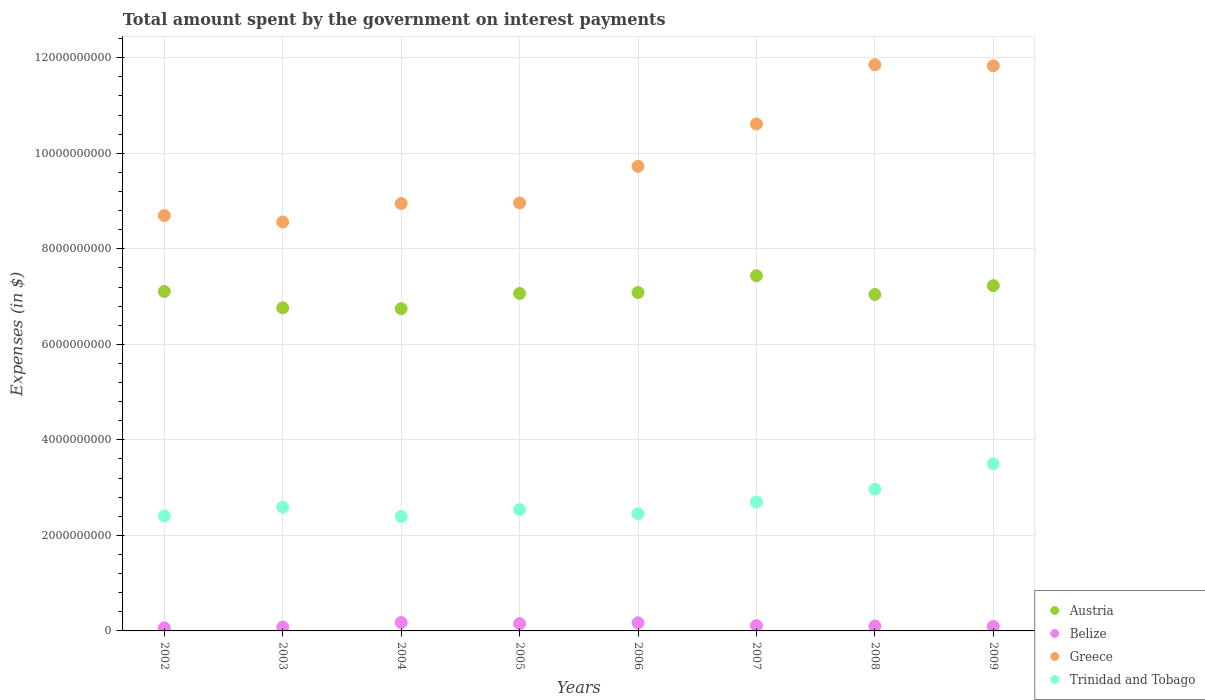What is the amount spent on interest payments by the government in Belize in 2004?
Give a very brief answer. 1.76e+08. Across all years, what is the maximum amount spent on interest payments by the government in Belize?
Your answer should be compact. 1.76e+08. Across all years, what is the minimum amount spent on interest payments by the government in Greece?
Provide a short and direct response. 8.56e+09. In which year was the amount spent on interest payments by the government in Belize maximum?
Your answer should be compact. 2004. What is the total amount spent on interest payments by the government in Austria in the graph?
Ensure brevity in your answer.  5.65e+1. What is the difference between the amount spent on interest payments by the government in Austria in 2002 and that in 2007?
Keep it short and to the point. -3.29e+08. What is the difference between the amount spent on interest payments by the government in Austria in 2003 and the amount spent on interest payments by the government in Trinidad and Tobago in 2005?
Make the answer very short. 4.22e+09. What is the average amount spent on interest payments by the government in Greece per year?
Keep it short and to the point. 9.90e+09. In the year 2005, what is the difference between the amount spent on interest payments by the government in Austria and amount spent on interest payments by the government in Greece?
Your response must be concise. -1.90e+09. In how many years, is the amount spent on interest payments by the government in Trinidad and Tobago greater than 3600000000 $?
Provide a succinct answer. 0. What is the ratio of the amount spent on interest payments by the government in Greece in 2008 to that in 2009?
Provide a succinct answer. 1. Is the amount spent on interest payments by the government in Greece in 2003 less than that in 2009?
Your answer should be very brief. Yes. Is the difference between the amount spent on interest payments by the government in Austria in 2002 and 2003 greater than the difference between the amount spent on interest payments by the government in Greece in 2002 and 2003?
Provide a short and direct response. Yes. What is the difference between the highest and the second highest amount spent on interest payments by the government in Greece?
Your answer should be very brief. 2.30e+07. What is the difference between the highest and the lowest amount spent on interest payments by the government in Trinidad and Tobago?
Provide a short and direct response. 1.10e+09. Is the sum of the amount spent on interest payments by the government in Austria in 2003 and 2005 greater than the maximum amount spent on interest payments by the government in Trinidad and Tobago across all years?
Your answer should be very brief. Yes. Is it the case that in every year, the sum of the amount spent on interest payments by the government in Trinidad and Tobago and amount spent on interest payments by the government in Belize  is greater than the sum of amount spent on interest payments by the government in Austria and amount spent on interest payments by the government in Greece?
Give a very brief answer. No. Is it the case that in every year, the sum of the amount spent on interest payments by the government in Austria and amount spent on interest payments by the government in Greece  is greater than the amount spent on interest payments by the government in Belize?
Make the answer very short. Yes. Is the amount spent on interest payments by the government in Belize strictly less than the amount spent on interest payments by the government in Trinidad and Tobago over the years?
Offer a very short reply. Yes. How many years are there in the graph?
Your answer should be very brief. 8. Where does the legend appear in the graph?
Give a very brief answer. Bottom right. How many legend labels are there?
Offer a terse response. 4. What is the title of the graph?
Offer a terse response. Total amount spent by the government on interest payments. Does "Canada" appear as one of the legend labels in the graph?
Your answer should be very brief. No. What is the label or title of the Y-axis?
Offer a terse response. Expenses (in $). What is the Expenses (in $) in Austria in 2002?
Offer a terse response. 7.11e+09. What is the Expenses (in $) of Belize in 2002?
Your answer should be very brief. 6.39e+07. What is the Expenses (in $) of Greece in 2002?
Keep it short and to the point. 8.70e+09. What is the Expenses (in $) in Trinidad and Tobago in 2002?
Provide a short and direct response. 2.41e+09. What is the Expenses (in $) of Austria in 2003?
Provide a succinct answer. 6.76e+09. What is the Expenses (in $) in Belize in 2003?
Give a very brief answer. 8.13e+07. What is the Expenses (in $) in Greece in 2003?
Offer a terse response. 8.56e+09. What is the Expenses (in $) in Trinidad and Tobago in 2003?
Provide a short and direct response. 2.59e+09. What is the Expenses (in $) in Austria in 2004?
Your answer should be very brief. 6.75e+09. What is the Expenses (in $) of Belize in 2004?
Your answer should be compact. 1.76e+08. What is the Expenses (in $) in Greece in 2004?
Provide a short and direct response. 8.95e+09. What is the Expenses (in $) of Trinidad and Tobago in 2004?
Provide a succinct answer. 2.40e+09. What is the Expenses (in $) in Austria in 2005?
Your answer should be very brief. 7.06e+09. What is the Expenses (in $) of Belize in 2005?
Ensure brevity in your answer.  1.54e+08. What is the Expenses (in $) in Greece in 2005?
Offer a very short reply. 8.96e+09. What is the Expenses (in $) in Trinidad and Tobago in 2005?
Offer a very short reply. 2.54e+09. What is the Expenses (in $) of Austria in 2006?
Give a very brief answer. 7.09e+09. What is the Expenses (in $) of Belize in 2006?
Your response must be concise. 1.70e+08. What is the Expenses (in $) in Greece in 2006?
Keep it short and to the point. 9.73e+09. What is the Expenses (in $) of Trinidad and Tobago in 2006?
Offer a terse response. 2.45e+09. What is the Expenses (in $) of Austria in 2007?
Give a very brief answer. 7.44e+09. What is the Expenses (in $) in Belize in 2007?
Offer a terse response. 1.11e+08. What is the Expenses (in $) of Greece in 2007?
Offer a terse response. 1.06e+1. What is the Expenses (in $) in Trinidad and Tobago in 2007?
Provide a succinct answer. 2.70e+09. What is the Expenses (in $) in Austria in 2008?
Provide a short and direct response. 7.04e+09. What is the Expenses (in $) in Belize in 2008?
Your response must be concise. 1.02e+08. What is the Expenses (in $) in Greece in 2008?
Offer a terse response. 1.19e+1. What is the Expenses (in $) in Trinidad and Tobago in 2008?
Give a very brief answer. 2.97e+09. What is the Expenses (in $) in Austria in 2009?
Your answer should be very brief. 7.23e+09. What is the Expenses (in $) of Belize in 2009?
Offer a terse response. 9.58e+07. What is the Expenses (in $) in Greece in 2009?
Offer a very short reply. 1.18e+1. What is the Expenses (in $) in Trinidad and Tobago in 2009?
Your answer should be compact. 3.50e+09. Across all years, what is the maximum Expenses (in $) of Austria?
Provide a succinct answer. 7.44e+09. Across all years, what is the maximum Expenses (in $) in Belize?
Your answer should be compact. 1.76e+08. Across all years, what is the maximum Expenses (in $) of Greece?
Provide a short and direct response. 1.19e+1. Across all years, what is the maximum Expenses (in $) in Trinidad and Tobago?
Keep it short and to the point. 3.50e+09. Across all years, what is the minimum Expenses (in $) of Austria?
Your response must be concise. 6.75e+09. Across all years, what is the minimum Expenses (in $) of Belize?
Ensure brevity in your answer.  6.39e+07. Across all years, what is the minimum Expenses (in $) of Greece?
Provide a succinct answer. 8.56e+09. Across all years, what is the minimum Expenses (in $) in Trinidad and Tobago?
Your answer should be compact. 2.40e+09. What is the total Expenses (in $) in Austria in the graph?
Give a very brief answer. 5.65e+1. What is the total Expenses (in $) in Belize in the graph?
Provide a succinct answer. 9.54e+08. What is the total Expenses (in $) in Greece in the graph?
Keep it short and to the point. 7.92e+1. What is the total Expenses (in $) in Trinidad and Tobago in the graph?
Provide a short and direct response. 2.16e+1. What is the difference between the Expenses (in $) of Austria in 2002 and that in 2003?
Provide a short and direct response. 3.42e+08. What is the difference between the Expenses (in $) of Belize in 2002 and that in 2003?
Offer a very short reply. -1.74e+07. What is the difference between the Expenses (in $) of Greece in 2002 and that in 2003?
Offer a terse response. 1.35e+08. What is the difference between the Expenses (in $) of Trinidad and Tobago in 2002 and that in 2003?
Make the answer very short. -1.83e+08. What is the difference between the Expenses (in $) in Austria in 2002 and that in 2004?
Provide a succinct answer. 3.60e+08. What is the difference between the Expenses (in $) in Belize in 2002 and that in 2004?
Make the answer very short. -1.12e+08. What is the difference between the Expenses (in $) in Greece in 2002 and that in 2004?
Provide a succinct answer. -2.52e+08. What is the difference between the Expenses (in $) in Trinidad and Tobago in 2002 and that in 2004?
Ensure brevity in your answer.  1.27e+07. What is the difference between the Expenses (in $) of Austria in 2002 and that in 2005?
Give a very brief answer. 4.20e+07. What is the difference between the Expenses (in $) of Belize in 2002 and that in 2005?
Keep it short and to the point. -8.98e+07. What is the difference between the Expenses (in $) of Greece in 2002 and that in 2005?
Keep it short and to the point. -2.64e+08. What is the difference between the Expenses (in $) of Trinidad and Tobago in 2002 and that in 2005?
Make the answer very short. -1.32e+08. What is the difference between the Expenses (in $) of Austria in 2002 and that in 2006?
Offer a very short reply. 2.17e+07. What is the difference between the Expenses (in $) in Belize in 2002 and that in 2006?
Provide a short and direct response. -1.06e+08. What is the difference between the Expenses (in $) of Greece in 2002 and that in 2006?
Offer a very short reply. -1.03e+09. What is the difference between the Expenses (in $) in Trinidad and Tobago in 2002 and that in 2006?
Give a very brief answer. -4.43e+07. What is the difference between the Expenses (in $) of Austria in 2002 and that in 2007?
Your response must be concise. -3.29e+08. What is the difference between the Expenses (in $) of Belize in 2002 and that in 2007?
Your response must be concise. -4.73e+07. What is the difference between the Expenses (in $) in Greece in 2002 and that in 2007?
Your response must be concise. -1.92e+09. What is the difference between the Expenses (in $) of Trinidad and Tobago in 2002 and that in 2007?
Offer a terse response. -2.89e+08. What is the difference between the Expenses (in $) in Austria in 2002 and that in 2008?
Offer a very short reply. 6.27e+07. What is the difference between the Expenses (in $) in Belize in 2002 and that in 2008?
Your answer should be very brief. -3.84e+07. What is the difference between the Expenses (in $) in Greece in 2002 and that in 2008?
Your answer should be very brief. -3.16e+09. What is the difference between the Expenses (in $) in Trinidad and Tobago in 2002 and that in 2008?
Offer a terse response. -5.58e+08. What is the difference between the Expenses (in $) of Austria in 2002 and that in 2009?
Give a very brief answer. -1.21e+08. What is the difference between the Expenses (in $) in Belize in 2002 and that in 2009?
Make the answer very short. -3.19e+07. What is the difference between the Expenses (in $) of Greece in 2002 and that in 2009?
Make the answer very short. -3.13e+09. What is the difference between the Expenses (in $) of Trinidad and Tobago in 2002 and that in 2009?
Your answer should be very brief. -1.09e+09. What is the difference between the Expenses (in $) in Austria in 2003 and that in 2004?
Ensure brevity in your answer.  1.82e+07. What is the difference between the Expenses (in $) in Belize in 2003 and that in 2004?
Your answer should be very brief. -9.45e+07. What is the difference between the Expenses (in $) of Greece in 2003 and that in 2004?
Provide a short and direct response. -3.87e+08. What is the difference between the Expenses (in $) in Trinidad and Tobago in 2003 and that in 2004?
Ensure brevity in your answer.  1.96e+08. What is the difference between the Expenses (in $) of Austria in 2003 and that in 2005?
Provide a succinct answer. -3.00e+08. What is the difference between the Expenses (in $) in Belize in 2003 and that in 2005?
Ensure brevity in your answer.  -7.24e+07. What is the difference between the Expenses (in $) in Greece in 2003 and that in 2005?
Ensure brevity in your answer.  -3.99e+08. What is the difference between the Expenses (in $) of Trinidad and Tobago in 2003 and that in 2005?
Keep it short and to the point. 5.04e+07. What is the difference between the Expenses (in $) in Austria in 2003 and that in 2006?
Offer a very short reply. -3.20e+08. What is the difference between the Expenses (in $) of Belize in 2003 and that in 2006?
Give a very brief answer. -8.89e+07. What is the difference between the Expenses (in $) of Greece in 2003 and that in 2006?
Your response must be concise. -1.16e+09. What is the difference between the Expenses (in $) in Trinidad and Tobago in 2003 and that in 2006?
Your answer should be compact. 1.39e+08. What is the difference between the Expenses (in $) in Austria in 2003 and that in 2007?
Offer a very short reply. -6.72e+08. What is the difference between the Expenses (in $) of Belize in 2003 and that in 2007?
Ensure brevity in your answer.  -2.99e+07. What is the difference between the Expenses (in $) of Greece in 2003 and that in 2007?
Give a very brief answer. -2.05e+09. What is the difference between the Expenses (in $) in Trinidad and Tobago in 2003 and that in 2007?
Provide a short and direct response. -1.06e+08. What is the difference between the Expenses (in $) of Austria in 2003 and that in 2008?
Your answer should be compact. -2.80e+08. What is the difference between the Expenses (in $) of Belize in 2003 and that in 2008?
Your response must be concise. -2.10e+07. What is the difference between the Expenses (in $) in Greece in 2003 and that in 2008?
Offer a terse response. -3.29e+09. What is the difference between the Expenses (in $) of Trinidad and Tobago in 2003 and that in 2008?
Offer a very short reply. -3.75e+08. What is the difference between the Expenses (in $) in Austria in 2003 and that in 2009?
Offer a very short reply. -4.64e+08. What is the difference between the Expenses (in $) in Belize in 2003 and that in 2009?
Offer a very short reply. -1.45e+07. What is the difference between the Expenses (in $) in Greece in 2003 and that in 2009?
Ensure brevity in your answer.  -3.27e+09. What is the difference between the Expenses (in $) of Trinidad and Tobago in 2003 and that in 2009?
Give a very brief answer. -9.08e+08. What is the difference between the Expenses (in $) of Austria in 2004 and that in 2005?
Provide a succinct answer. -3.18e+08. What is the difference between the Expenses (in $) in Belize in 2004 and that in 2005?
Make the answer very short. 2.21e+07. What is the difference between the Expenses (in $) in Greece in 2004 and that in 2005?
Offer a terse response. -1.20e+07. What is the difference between the Expenses (in $) of Trinidad and Tobago in 2004 and that in 2005?
Give a very brief answer. -1.45e+08. What is the difference between the Expenses (in $) of Austria in 2004 and that in 2006?
Keep it short and to the point. -3.39e+08. What is the difference between the Expenses (in $) of Belize in 2004 and that in 2006?
Make the answer very short. 5.65e+06. What is the difference between the Expenses (in $) in Greece in 2004 and that in 2006?
Your answer should be very brief. -7.78e+08. What is the difference between the Expenses (in $) in Trinidad and Tobago in 2004 and that in 2006?
Provide a short and direct response. -5.70e+07. What is the difference between the Expenses (in $) in Austria in 2004 and that in 2007?
Provide a short and direct response. -6.90e+08. What is the difference between the Expenses (in $) of Belize in 2004 and that in 2007?
Provide a short and direct response. 6.47e+07. What is the difference between the Expenses (in $) in Greece in 2004 and that in 2007?
Offer a terse response. -1.66e+09. What is the difference between the Expenses (in $) of Trinidad and Tobago in 2004 and that in 2007?
Your answer should be very brief. -3.02e+08. What is the difference between the Expenses (in $) of Austria in 2004 and that in 2008?
Ensure brevity in your answer.  -2.98e+08. What is the difference between the Expenses (in $) in Belize in 2004 and that in 2008?
Ensure brevity in your answer.  7.35e+07. What is the difference between the Expenses (in $) of Greece in 2004 and that in 2008?
Keep it short and to the point. -2.90e+09. What is the difference between the Expenses (in $) in Trinidad and Tobago in 2004 and that in 2008?
Give a very brief answer. -5.71e+08. What is the difference between the Expenses (in $) in Austria in 2004 and that in 2009?
Make the answer very short. -4.82e+08. What is the difference between the Expenses (in $) of Belize in 2004 and that in 2009?
Give a very brief answer. 8.01e+07. What is the difference between the Expenses (in $) of Greece in 2004 and that in 2009?
Offer a terse response. -2.88e+09. What is the difference between the Expenses (in $) in Trinidad and Tobago in 2004 and that in 2009?
Make the answer very short. -1.10e+09. What is the difference between the Expenses (in $) of Austria in 2005 and that in 2006?
Offer a very short reply. -2.02e+07. What is the difference between the Expenses (in $) of Belize in 2005 and that in 2006?
Give a very brief answer. -1.65e+07. What is the difference between the Expenses (in $) of Greece in 2005 and that in 2006?
Offer a very short reply. -7.66e+08. What is the difference between the Expenses (in $) in Trinidad and Tobago in 2005 and that in 2006?
Your answer should be compact. 8.82e+07. What is the difference between the Expenses (in $) in Austria in 2005 and that in 2007?
Your answer should be compact. -3.71e+08. What is the difference between the Expenses (in $) of Belize in 2005 and that in 2007?
Your response must be concise. 4.26e+07. What is the difference between the Expenses (in $) of Greece in 2005 and that in 2007?
Your answer should be very brief. -1.65e+09. What is the difference between the Expenses (in $) in Trinidad and Tobago in 2005 and that in 2007?
Your answer should be compact. -1.57e+08. What is the difference between the Expenses (in $) in Austria in 2005 and that in 2008?
Make the answer very short. 2.08e+07. What is the difference between the Expenses (in $) of Belize in 2005 and that in 2008?
Provide a short and direct response. 5.14e+07. What is the difference between the Expenses (in $) of Greece in 2005 and that in 2008?
Your response must be concise. -2.89e+09. What is the difference between the Expenses (in $) of Trinidad and Tobago in 2005 and that in 2008?
Keep it short and to the point. -4.26e+08. What is the difference between the Expenses (in $) of Austria in 2005 and that in 2009?
Your answer should be very brief. -1.63e+08. What is the difference between the Expenses (in $) in Belize in 2005 and that in 2009?
Your answer should be very brief. 5.80e+07. What is the difference between the Expenses (in $) of Greece in 2005 and that in 2009?
Keep it short and to the point. -2.87e+09. What is the difference between the Expenses (in $) of Trinidad and Tobago in 2005 and that in 2009?
Offer a terse response. -9.58e+08. What is the difference between the Expenses (in $) in Austria in 2006 and that in 2007?
Ensure brevity in your answer.  -3.51e+08. What is the difference between the Expenses (in $) of Belize in 2006 and that in 2007?
Your answer should be very brief. 5.90e+07. What is the difference between the Expenses (in $) in Greece in 2006 and that in 2007?
Your answer should be compact. -8.87e+08. What is the difference between the Expenses (in $) in Trinidad and Tobago in 2006 and that in 2007?
Your response must be concise. -2.45e+08. What is the difference between the Expenses (in $) in Austria in 2006 and that in 2008?
Provide a succinct answer. 4.10e+07. What is the difference between the Expenses (in $) of Belize in 2006 and that in 2008?
Give a very brief answer. 6.79e+07. What is the difference between the Expenses (in $) of Greece in 2006 and that in 2008?
Keep it short and to the point. -2.13e+09. What is the difference between the Expenses (in $) of Trinidad and Tobago in 2006 and that in 2008?
Provide a succinct answer. -5.14e+08. What is the difference between the Expenses (in $) in Austria in 2006 and that in 2009?
Offer a terse response. -1.43e+08. What is the difference between the Expenses (in $) in Belize in 2006 and that in 2009?
Keep it short and to the point. 7.44e+07. What is the difference between the Expenses (in $) in Greece in 2006 and that in 2009?
Ensure brevity in your answer.  -2.10e+09. What is the difference between the Expenses (in $) in Trinidad and Tobago in 2006 and that in 2009?
Ensure brevity in your answer.  -1.05e+09. What is the difference between the Expenses (in $) of Austria in 2007 and that in 2008?
Your answer should be very brief. 3.92e+08. What is the difference between the Expenses (in $) in Belize in 2007 and that in 2008?
Your response must be concise. 8.84e+06. What is the difference between the Expenses (in $) of Greece in 2007 and that in 2008?
Your answer should be compact. -1.24e+09. What is the difference between the Expenses (in $) in Trinidad and Tobago in 2007 and that in 2008?
Your response must be concise. -2.69e+08. What is the difference between the Expenses (in $) in Austria in 2007 and that in 2009?
Ensure brevity in your answer.  2.08e+08. What is the difference between the Expenses (in $) of Belize in 2007 and that in 2009?
Give a very brief answer. 1.54e+07. What is the difference between the Expenses (in $) of Greece in 2007 and that in 2009?
Make the answer very short. -1.22e+09. What is the difference between the Expenses (in $) of Trinidad and Tobago in 2007 and that in 2009?
Provide a succinct answer. -8.02e+08. What is the difference between the Expenses (in $) of Austria in 2008 and that in 2009?
Ensure brevity in your answer.  -1.84e+08. What is the difference between the Expenses (in $) in Belize in 2008 and that in 2009?
Provide a short and direct response. 6.55e+06. What is the difference between the Expenses (in $) in Greece in 2008 and that in 2009?
Provide a short and direct response. 2.30e+07. What is the difference between the Expenses (in $) of Trinidad and Tobago in 2008 and that in 2009?
Your answer should be very brief. -5.33e+08. What is the difference between the Expenses (in $) of Austria in 2002 and the Expenses (in $) of Belize in 2003?
Give a very brief answer. 7.03e+09. What is the difference between the Expenses (in $) of Austria in 2002 and the Expenses (in $) of Greece in 2003?
Your answer should be very brief. -1.46e+09. What is the difference between the Expenses (in $) of Austria in 2002 and the Expenses (in $) of Trinidad and Tobago in 2003?
Make the answer very short. 4.51e+09. What is the difference between the Expenses (in $) of Belize in 2002 and the Expenses (in $) of Greece in 2003?
Give a very brief answer. -8.50e+09. What is the difference between the Expenses (in $) in Belize in 2002 and the Expenses (in $) in Trinidad and Tobago in 2003?
Your answer should be compact. -2.53e+09. What is the difference between the Expenses (in $) of Greece in 2002 and the Expenses (in $) of Trinidad and Tobago in 2003?
Provide a succinct answer. 6.11e+09. What is the difference between the Expenses (in $) in Austria in 2002 and the Expenses (in $) in Belize in 2004?
Provide a succinct answer. 6.93e+09. What is the difference between the Expenses (in $) of Austria in 2002 and the Expenses (in $) of Greece in 2004?
Provide a short and direct response. -1.84e+09. What is the difference between the Expenses (in $) of Austria in 2002 and the Expenses (in $) of Trinidad and Tobago in 2004?
Your answer should be very brief. 4.71e+09. What is the difference between the Expenses (in $) in Belize in 2002 and the Expenses (in $) in Greece in 2004?
Make the answer very short. -8.89e+09. What is the difference between the Expenses (in $) of Belize in 2002 and the Expenses (in $) of Trinidad and Tobago in 2004?
Give a very brief answer. -2.33e+09. What is the difference between the Expenses (in $) of Greece in 2002 and the Expenses (in $) of Trinidad and Tobago in 2004?
Keep it short and to the point. 6.30e+09. What is the difference between the Expenses (in $) of Austria in 2002 and the Expenses (in $) of Belize in 2005?
Your response must be concise. 6.95e+09. What is the difference between the Expenses (in $) in Austria in 2002 and the Expenses (in $) in Greece in 2005?
Offer a very short reply. -1.85e+09. What is the difference between the Expenses (in $) of Austria in 2002 and the Expenses (in $) of Trinidad and Tobago in 2005?
Your answer should be compact. 4.57e+09. What is the difference between the Expenses (in $) of Belize in 2002 and the Expenses (in $) of Greece in 2005?
Your response must be concise. -8.90e+09. What is the difference between the Expenses (in $) in Belize in 2002 and the Expenses (in $) in Trinidad and Tobago in 2005?
Your answer should be very brief. -2.48e+09. What is the difference between the Expenses (in $) of Greece in 2002 and the Expenses (in $) of Trinidad and Tobago in 2005?
Provide a short and direct response. 6.16e+09. What is the difference between the Expenses (in $) in Austria in 2002 and the Expenses (in $) in Belize in 2006?
Provide a short and direct response. 6.94e+09. What is the difference between the Expenses (in $) of Austria in 2002 and the Expenses (in $) of Greece in 2006?
Provide a short and direct response. -2.62e+09. What is the difference between the Expenses (in $) in Austria in 2002 and the Expenses (in $) in Trinidad and Tobago in 2006?
Give a very brief answer. 4.65e+09. What is the difference between the Expenses (in $) in Belize in 2002 and the Expenses (in $) in Greece in 2006?
Ensure brevity in your answer.  -9.66e+09. What is the difference between the Expenses (in $) in Belize in 2002 and the Expenses (in $) in Trinidad and Tobago in 2006?
Offer a terse response. -2.39e+09. What is the difference between the Expenses (in $) of Greece in 2002 and the Expenses (in $) of Trinidad and Tobago in 2006?
Your answer should be very brief. 6.24e+09. What is the difference between the Expenses (in $) in Austria in 2002 and the Expenses (in $) in Belize in 2007?
Your answer should be compact. 7.00e+09. What is the difference between the Expenses (in $) of Austria in 2002 and the Expenses (in $) of Greece in 2007?
Keep it short and to the point. -3.51e+09. What is the difference between the Expenses (in $) in Austria in 2002 and the Expenses (in $) in Trinidad and Tobago in 2007?
Your answer should be compact. 4.41e+09. What is the difference between the Expenses (in $) of Belize in 2002 and the Expenses (in $) of Greece in 2007?
Your response must be concise. -1.06e+1. What is the difference between the Expenses (in $) of Belize in 2002 and the Expenses (in $) of Trinidad and Tobago in 2007?
Your answer should be compact. -2.63e+09. What is the difference between the Expenses (in $) in Greece in 2002 and the Expenses (in $) in Trinidad and Tobago in 2007?
Your answer should be very brief. 6.00e+09. What is the difference between the Expenses (in $) of Austria in 2002 and the Expenses (in $) of Belize in 2008?
Provide a succinct answer. 7.00e+09. What is the difference between the Expenses (in $) in Austria in 2002 and the Expenses (in $) in Greece in 2008?
Make the answer very short. -4.75e+09. What is the difference between the Expenses (in $) of Austria in 2002 and the Expenses (in $) of Trinidad and Tobago in 2008?
Your answer should be compact. 4.14e+09. What is the difference between the Expenses (in $) of Belize in 2002 and the Expenses (in $) of Greece in 2008?
Offer a terse response. -1.18e+1. What is the difference between the Expenses (in $) in Belize in 2002 and the Expenses (in $) in Trinidad and Tobago in 2008?
Your answer should be very brief. -2.90e+09. What is the difference between the Expenses (in $) in Greece in 2002 and the Expenses (in $) in Trinidad and Tobago in 2008?
Your answer should be very brief. 5.73e+09. What is the difference between the Expenses (in $) of Austria in 2002 and the Expenses (in $) of Belize in 2009?
Keep it short and to the point. 7.01e+09. What is the difference between the Expenses (in $) in Austria in 2002 and the Expenses (in $) in Greece in 2009?
Give a very brief answer. -4.72e+09. What is the difference between the Expenses (in $) in Austria in 2002 and the Expenses (in $) in Trinidad and Tobago in 2009?
Offer a terse response. 3.61e+09. What is the difference between the Expenses (in $) of Belize in 2002 and the Expenses (in $) of Greece in 2009?
Make the answer very short. -1.18e+1. What is the difference between the Expenses (in $) of Belize in 2002 and the Expenses (in $) of Trinidad and Tobago in 2009?
Offer a very short reply. -3.44e+09. What is the difference between the Expenses (in $) of Greece in 2002 and the Expenses (in $) of Trinidad and Tobago in 2009?
Keep it short and to the point. 5.20e+09. What is the difference between the Expenses (in $) in Austria in 2003 and the Expenses (in $) in Belize in 2004?
Your response must be concise. 6.59e+09. What is the difference between the Expenses (in $) in Austria in 2003 and the Expenses (in $) in Greece in 2004?
Your response must be concise. -2.18e+09. What is the difference between the Expenses (in $) in Austria in 2003 and the Expenses (in $) in Trinidad and Tobago in 2004?
Your response must be concise. 4.37e+09. What is the difference between the Expenses (in $) of Belize in 2003 and the Expenses (in $) of Greece in 2004?
Ensure brevity in your answer.  -8.87e+09. What is the difference between the Expenses (in $) in Belize in 2003 and the Expenses (in $) in Trinidad and Tobago in 2004?
Provide a short and direct response. -2.31e+09. What is the difference between the Expenses (in $) in Greece in 2003 and the Expenses (in $) in Trinidad and Tobago in 2004?
Your answer should be compact. 6.17e+09. What is the difference between the Expenses (in $) of Austria in 2003 and the Expenses (in $) of Belize in 2005?
Make the answer very short. 6.61e+09. What is the difference between the Expenses (in $) in Austria in 2003 and the Expenses (in $) in Greece in 2005?
Ensure brevity in your answer.  -2.20e+09. What is the difference between the Expenses (in $) in Austria in 2003 and the Expenses (in $) in Trinidad and Tobago in 2005?
Your response must be concise. 4.22e+09. What is the difference between the Expenses (in $) in Belize in 2003 and the Expenses (in $) in Greece in 2005?
Keep it short and to the point. -8.88e+09. What is the difference between the Expenses (in $) in Belize in 2003 and the Expenses (in $) in Trinidad and Tobago in 2005?
Give a very brief answer. -2.46e+09. What is the difference between the Expenses (in $) in Greece in 2003 and the Expenses (in $) in Trinidad and Tobago in 2005?
Your answer should be very brief. 6.02e+09. What is the difference between the Expenses (in $) in Austria in 2003 and the Expenses (in $) in Belize in 2006?
Make the answer very short. 6.59e+09. What is the difference between the Expenses (in $) of Austria in 2003 and the Expenses (in $) of Greece in 2006?
Ensure brevity in your answer.  -2.96e+09. What is the difference between the Expenses (in $) in Austria in 2003 and the Expenses (in $) in Trinidad and Tobago in 2006?
Give a very brief answer. 4.31e+09. What is the difference between the Expenses (in $) of Belize in 2003 and the Expenses (in $) of Greece in 2006?
Ensure brevity in your answer.  -9.65e+09. What is the difference between the Expenses (in $) of Belize in 2003 and the Expenses (in $) of Trinidad and Tobago in 2006?
Your response must be concise. -2.37e+09. What is the difference between the Expenses (in $) of Greece in 2003 and the Expenses (in $) of Trinidad and Tobago in 2006?
Offer a very short reply. 6.11e+09. What is the difference between the Expenses (in $) in Austria in 2003 and the Expenses (in $) in Belize in 2007?
Offer a very short reply. 6.65e+09. What is the difference between the Expenses (in $) of Austria in 2003 and the Expenses (in $) of Greece in 2007?
Offer a very short reply. -3.85e+09. What is the difference between the Expenses (in $) of Austria in 2003 and the Expenses (in $) of Trinidad and Tobago in 2007?
Make the answer very short. 4.07e+09. What is the difference between the Expenses (in $) of Belize in 2003 and the Expenses (in $) of Greece in 2007?
Keep it short and to the point. -1.05e+1. What is the difference between the Expenses (in $) in Belize in 2003 and the Expenses (in $) in Trinidad and Tobago in 2007?
Make the answer very short. -2.62e+09. What is the difference between the Expenses (in $) of Greece in 2003 and the Expenses (in $) of Trinidad and Tobago in 2007?
Give a very brief answer. 5.86e+09. What is the difference between the Expenses (in $) in Austria in 2003 and the Expenses (in $) in Belize in 2008?
Your answer should be compact. 6.66e+09. What is the difference between the Expenses (in $) in Austria in 2003 and the Expenses (in $) in Greece in 2008?
Ensure brevity in your answer.  -5.09e+09. What is the difference between the Expenses (in $) of Austria in 2003 and the Expenses (in $) of Trinidad and Tobago in 2008?
Keep it short and to the point. 3.80e+09. What is the difference between the Expenses (in $) in Belize in 2003 and the Expenses (in $) in Greece in 2008?
Make the answer very short. -1.18e+1. What is the difference between the Expenses (in $) in Belize in 2003 and the Expenses (in $) in Trinidad and Tobago in 2008?
Your answer should be very brief. -2.89e+09. What is the difference between the Expenses (in $) in Greece in 2003 and the Expenses (in $) in Trinidad and Tobago in 2008?
Offer a very short reply. 5.59e+09. What is the difference between the Expenses (in $) in Austria in 2003 and the Expenses (in $) in Belize in 2009?
Give a very brief answer. 6.67e+09. What is the difference between the Expenses (in $) in Austria in 2003 and the Expenses (in $) in Greece in 2009?
Offer a very short reply. -5.07e+09. What is the difference between the Expenses (in $) of Austria in 2003 and the Expenses (in $) of Trinidad and Tobago in 2009?
Keep it short and to the point. 3.26e+09. What is the difference between the Expenses (in $) in Belize in 2003 and the Expenses (in $) in Greece in 2009?
Make the answer very short. -1.17e+1. What is the difference between the Expenses (in $) in Belize in 2003 and the Expenses (in $) in Trinidad and Tobago in 2009?
Provide a short and direct response. -3.42e+09. What is the difference between the Expenses (in $) in Greece in 2003 and the Expenses (in $) in Trinidad and Tobago in 2009?
Provide a succinct answer. 5.06e+09. What is the difference between the Expenses (in $) of Austria in 2004 and the Expenses (in $) of Belize in 2005?
Give a very brief answer. 6.59e+09. What is the difference between the Expenses (in $) of Austria in 2004 and the Expenses (in $) of Greece in 2005?
Make the answer very short. -2.21e+09. What is the difference between the Expenses (in $) in Austria in 2004 and the Expenses (in $) in Trinidad and Tobago in 2005?
Your answer should be very brief. 4.20e+09. What is the difference between the Expenses (in $) in Belize in 2004 and the Expenses (in $) in Greece in 2005?
Give a very brief answer. -8.79e+09. What is the difference between the Expenses (in $) of Belize in 2004 and the Expenses (in $) of Trinidad and Tobago in 2005?
Your response must be concise. -2.37e+09. What is the difference between the Expenses (in $) in Greece in 2004 and the Expenses (in $) in Trinidad and Tobago in 2005?
Offer a very short reply. 6.41e+09. What is the difference between the Expenses (in $) in Austria in 2004 and the Expenses (in $) in Belize in 2006?
Your response must be concise. 6.58e+09. What is the difference between the Expenses (in $) of Austria in 2004 and the Expenses (in $) of Greece in 2006?
Make the answer very short. -2.98e+09. What is the difference between the Expenses (in $) of Austria in 2004 and the Expenses (in $) of Trinidad and Tobago in 2006?
Provide a short and direct response. 4.29e+09. What is the difference between the Expenses (in $) of Belize in 2004 and the Expenses (in $) of Greece in 2006?
Your response must be concise. -9.55e+09. What is the difference between the Expenses (in $) of Belize in 2004 and the Expenses (in $) of Trinidad and Tobago in 2006?
Your answer should be compact. -2.28e+09. What is the difference between the Expenses (in $) in Greece in 2004 and the Expenses (in $) in Trinidad and Tobago in 2006?
Ensure brevity in your answer.  6.50e+09. What is the difference between the Expenses (in $) in Austria in 2004 and the Expenses (in $) in Belize in 2007?
Give a very brief answer. 6.64e+09. What is the difference between the Expenses (in $) of Austria in 2004 and the Expenses (in $) of Greece in 2007?
Give a very brief answer. -3.87e+09. What is the difference between the Expenses (in $) of Austria in 2004 and the Expenses (in $) of Trinidad and Tobago in 2007?
Your answer should be compact. 4.05e+09. What is the difference between the Expenses (in $) of Belize in 2004 and the Expenses (in $) of Greece in 2007?
Keep it short and to the point. -1.04e+1. What is the difference between the Expenses (in $) of Belize in 2004 and the Expenses (in $) of Trinidad and Tobago in 2007?
Keep it short and to the point. -2.52e+09. What is the difference between the Expenses (in $) in Greece in 2004 and the Expenses (in $) in Trinidad and Tobago in 2007?
Offer a terse response. 6.25e+09. What is the difference between the Expenses (in $) in Austria in 2004 and the Expenses (in $) in Belize in 2008?
Offer a very short reply. 6.64e+09. What is the difference between the Expenses (in $) of Austria in 2004 and the Expenses (in $) of Greece in 2008?
Make the answer very short. -5.11e+09. What is the difference between the Expenses (in $) in Austria in 2004 and the Expenses (in $) in Trinidad and Tobago in 2008?
Give a very brief answer. 3.78e+09. What is the difference between the Expenses (in $) of Belize in 2004 and the Expenses (in $) of Greece in 2008?
Make the answer very short. -1.17e+1. What is the difference between the Expenses (in $) in Belize in 2004 and the Expenses (in $) in Trinidad and Tobago in 2008?
Keep it short and to the point. -2.79e+09. What is the difference between the Expenses (in $) of Greece in 2004 and the Expenses (in $) of Trinidad and Tobago in 2008?
Ensure brevity in your answer.  5.98e+09. What is the difference between the Expenses (in $) of Austria in 2004 and the Expenses (in $) of Belize in 2009?
Your answer should be very brief. 6.65e+09. What is the difference between the Expenses (in $) in Austria in 2004 and the Expenses (in $) in Greece in 2009?
Ensure brevity in your answer.  -5.08e+09. What is the difference between the Expenses (in $) in Austria in 2004 and the Expenses (in $) in Trinidad and Tobago in 2009?
Offer a very short reply. 3.25e+09. What is the difference between the Expenses (in $) in Belize in 2004 and the Expenses (in $) in Greece in 2009?
Keep it short and to the point. -1.17e+1. What is the difference between the Expenses (in $) in Belize in 2004 and the Expenses (in $) in Trinidad and Tobago in 2009?
Offer a very short reply. -3.32e+09. What is the difference between the Expenses (in $) of Greece in 2004 and the Expenses (in $) of Trinidad and Tobago in 2009?
Provide a succinct answer. 5.45e+09. What is the difference between the Expenses (in $) in Austria in 2005 and the Expenses (in $) in Belize in 2006?
Provide a short and direct response. 6.89e+09. What is the difference between the Expenses (in $) of Austria in 2005 and the Expenses (in $) of Greece in 2006?
Make the answer very short. -2.66e+09. What is the difference between the Expenses (in $) in Austria in 2005 and the Expenses (in $) in Trinidad and Tobago in 2006?
Give a very brief answer. 4.61e+09. What is the difference between the Expenses (in $) in Belize in 2005 and the Expenses (in $) in Greece in 2006?
Provide a succinct answer. -9.57e+09. What is the difference between the Expenses (in $) of Belize in 2005 and the Expenses (in $) of Trinidad and Tobago in 2006?
Your answer should be very brief. -2.30e+09. What is the difference between the Expenses (in $) in Greece in 2005 and the Expenses (in $) in Trinidad and Tobago in 2006?
Your answer should be compact. 6.51e+09. What is the difference between the Expenses (in $) of Austria in 2005 and the Expenses (in $) of Belize in 2007?
Provide a succinct answer. 6.95e+09. What is the difference between the Expenses (in $) in Austria in 2005 and the Expenses (in $) in Greece in 2007?
Your response must be concise. -3.55e+09. What is the difference between the Expenses (in $) of Austria in 2005 and the Expenses (in $) of Trinidad and Tobago in 2007?
Provide a short and direct response. 4.37e+09. What is the difference between the Expenses (in $) of Belize in 2005 and the Expenses (in $) of Greece in 2007?
Provide a succinct answer. -1.05e+1. What is the difference between the Expenses (in $) in Belize in 2005 and the Expenses (in $) in Trinidad and Tobago in 2007?
Make the answer very short. -2.54e+09. What is the difference between the Expenses (in $) of Greece in 2005 and the Expenses (in $) of Trinidad and Tobago in 2007?
Your answer should be compact. 6.26e+09. What is the difference between the Expenses (in $) in Austria in 2005 and the Expenses (in $) in Belize in 2008?
Keep it short and to the point. 6.96e+09. What is the difference between the Expenses (in $) of Austria in 2005 and the Expenses (in $) of Greece in 2008?
Your response must be concise. -4.79e+09. What is the difference between the Expenses (in $) in Austria in 2005 and the Expenses (in $) in Trinidad and Tobago in 2008?
Provide a short and direct response. 4.10e+09. What is the difference between the Expenses (in $) in Belize in 2005 and the Expenses (in $) in Greece in 2008?
Ensure brevity in your answer.  -1.17e+1. What is the difference between the Expenses (in $) of Belize in 2005 and the Expenses (in $) of Trinidad and Tobago in 2008?
Give a very brief answer. -2.81e+09. What is the difference between the Expenses (in $) of Greece in 2005 and the Expenses (in $) of Trinidad and Tobago in 2008?
Your answer should be compact. 5.99e+09. What is the difference between the Expenses (in $) of Austria in 2005 and the Expenses (in $) of Belize in 2009?
Your answer should be compact. 6.97e+09. What is the difference between the Expenses (in $) of Austria in 2005 and the Expenses (in $) of Greece in 2009?
Give a very brief answer. -4.77e+09. What is the difference between the Expenses (in $) of Austria in 2005 and the Expenses (in $) of Trinidad and Tobago in 2009?
Provide a short and direct response. 3.56e+09. What is the difference between the Expenses (in $) of Belize in 2005 and the Expenses (in $) of Greece in 2009?
Offer a very short reply. -1.17e+1. What is the difference between the Expenses (in $) of Belize in 2005 and the Expenses (in $) of Trinidad and Tobago in 2009?
Your answer should be compact. -3.35e+09. What is the difference between the Expenses (in $) of Greece in 2005 and the Expenses (in $) of Trinidad and Tobago in 2009?
Offer a very short reply. 5.46e+09. What is the difference between the Expenses (in $) of Austria in 2006 and the Expenses (in $) of Belize in 2007?
Offer a very short reply. 6.97e+09. What is the difference between the Expenses (in $) in Austria in 2006 and the Expenses (in $) in Greece in 2007?
Offer a very short reply. -3.53e+09. What is the difference between the Expenses (in $) of Austria in 2006 and the Expenses (in $) of Trinidad and Tobago in 2007?
Provide a short and direct response. 4.39e+09. What is the difference between the Expenses (in $) in Belize in 2006 and the Expenses (in $) in Greece in 2007?
Your answer should be very brief. -1.04e+1. What is the difference between the Expenses (in $) of Belize in 2006 and the Expenses (in $) of Trinidad and Tobago in 2007?
Your answer should be very brief. -2.53e+09. What is the difference between the Expenses (in $) in Greece in 2006 and the Expenses (in $) in Trinidad and Tobago in 2007?
Make the answer very short. 7.03e+09. What is the difference between the Expenses (in $) of Austria in 2006 and the Expenses (in $) of Belize in 2008?
Offer a very short reply. 6.98e+09. What is the difference between the Expenses (in $) in Austria in 2006 and the Expenses (in $) in Greece in 2008?
Provide a succinct answer. -4.77e+09. What is the difference between the Expenses (in $) of Austria in 2006 and the Expenses (in $) of Trinidad and Tobago in 2008?
Keep it short and to the point. 4.12e+09. What is the difference between the Expenses (in $) of Belize in 2006 and the Expenses (in $) of Greece in 2008?
Provide a short and direct response. -1.17e+1. What is the difference between the Expenses (in $) of Belize in 2006 and the Expenses (in $) of Trinidad and Tobago in 2008?
Your answer should be very brief. -2.80e+09. What is the difference between the Expenses (in $) in Greece in 2006 and the Expenses (in $) in Trinidad and Tobago in 2008?
Offer a very short reply. 6.76e+09. What is the difference between the Expenses (in $) of Austria in 2006 and the Expenses (in $) of Belize in 2009?
Your response must be concise. 6.99e+09. What is the difference between the Expenses (in $) in Austria in 2006 and the Expenses (in $) in Greece in 2009?
Make the answer very short. -4.75e+09. What is the difference between the Expenses (in $) in Austria in 2006 and the Expenses (in $) in Trinidad and Tobago in 2009?
Your answer should be very brief. 3.59e+09. What is the difference between the Expenses (in $) of Belize in 2006 and the Expenses (in $) of Greece in 2009?
Your response must be concise. -1.17e+1. What is the difference between the Expenses (in $) in Belize in 2006 and the Expenses (in $) in Trinidad and Tobago in 2009?
Offer a very short reply. -3.33e+09. What is the difference between the Expenses (in $) in Greece in 2006 and the Expenses (in $) in Trinidad and Tobago in 2009?
Offer a very short reply. 6.23e+09. What is the difference between the Expenses (in $) in Austria in 2007 and the Expenses (in $) in Belize in 2008?
Make the answer very short. 7.33e+09. What is the difference between the Expenses (in $) of Austria in 2007 and the Expenses (in $) of Greece in 2008?
Make the answer very short. -4.42e+09. What is the difference between the Expenses (in $) in Austria in 2007 and the Expenses (in $) in Trinidad and Tobago in 2008?
Offer a very short reply. 4.47e+09. What is the difference between the Expenses (in $) in Belize in 2007 and the Expenses (in $) in Greece in 2008?
Provide a succinct answer. -1.17e+1. What is the difference between the Expenses (in $) in Belize in 2007 and the Expenses (in $) in Trinidad and Tobago in 2008?
Your answer should be compact. -2.86e+09. What is the difference between the Expenses (in $) of Greece in 2007 and the Expenses (in $) of Trinidad and Tobago in 2008?
Provide a short and direct response. 7.65e+09. What is the difference between the Expenses (in $) of Austria in 2007 and the Expenses (in $) of Belize in 2009?
Keep it short and to the point. 7.34e+09. What is the difference between the Expenses (in $) of Austria in 2007 and the Expenses (in $) of Greece in 2009?
Provide a succinct answer. -4.39e+09. What is the difference between the Expenses (in $) of Austria in 2007 and the Expenses (in $) of Trinidad and Tobago in 2009?
Your answer should be very brief. 3.94e+09. What is the difference between the Expenses (in $) in Belize in 2007 and the Expenses (in $) in Greece in 2009?
Your answer should be very brief. -1.17e+1. What is the difference between the Expenses (in $) of Belize in 2007 and the Expenses (in $) of Trinidad and Tobago in 2009?
Keep it short and to the point. -3.39e+09. What is the difference between the Expenses (in $) in Greece in 2007 and the Expenses (in $) in Trinidad and Tobago in 2009?
Offer a very short reply. 7.11e+09. What is the difference between the Expenses (in $) of Austria in 2008 and the Expenses (in $) of Belize in 2009?
Provide a short and direct response. 6.95e+09. What is the difference between the Expenses (in $) of Austria in 2008 and the Expenses (in $) of Greece in 2009?
Give a very brief answer. -4.79e+09. What is the difference between the Expenses (in $) of Austria in 2008 and the Expenses (in $) of Trinidad and Tobago in 2009?
Offer a terse response. 3.54e+09. What is the difference between the Expenses (in $) of Belize in 2008 and the Expenses (in $) of Greece in 2009?
Your response must be concise. -1.17e+1. What is the difference between the Expenses (in $) in Belize in 2008 and the Expenses (in $) in Trinidad and Tobago in 2009?
Your answer should be very brief. -3.40e+09. What is the difference between the Expenses (in $) in Greece in 2008 and the Expenses (in $) in Trinidad and Tobago in 2009?
Make the answer very short. 8.35e+09. What is the average Expenses (in $) of Austria per year?
Your answer should be compact. 7.06e+09. What is the average Expenses (in $) in Belize per year?
Make the answer very short. 1.19e+08. What is the average Expenses (in $) of Greece per year?
Ensure brevity in your answer.  9.90e+09. What is the average Expenses (in $) in Trinidad and Tobago per year?
Provide a short and direct response. 2.69e+09. In the year 2002, what is the difference between the Expenses (in $) in Austria and Expenses (in $) in Belize?
Provide a short and direct response. 7.04e+09. In the year 2002, what is the difference between the Expenses (in $) in Austria and Expenses (in $) in Greece?
Make the answer very short. -1.59e+09. In the year 2002, what is the difference between the Expenses (in $) in Austria and Expenses (in $) in Trinidad and Tobago?
Offer a very short reply. 4.70e+09. In the year 2002, what is the difference between the Expenses (in $) in Belize and Expenses (in $) in Greece?
Your answer should be compact. -8.63e+09. In the year 2002, what is the difference between the Expenses (in $) in Belize and Expenses (in $) in Trinidad and Tobago?
Offer a terse response. -2.35e+09. In the year 2002, what is the difference between the Expenses (in $) in Greece and Expenses (in $) in Trinidad and Tobago?
Keep it short and to the point. 6.29e+09. In the year 2003, what is the difference between the Expenses (in $) in Austria and Expenses (in $) in Belize?
Your response must be concise. 6.68e+09. In the year 2003, what is the difference between the Expenses (in $) of Austria and Expenses (in $) of Greece?
Keep it short and to the point. -1.80e+09. In the year 2003, what is the difference between the Expenses (in $) of Austria and Expenses (in $) of Trinidad and Tobago?
Offer a very short reply. 4.17e+09. In the year 2003, what is the difference between the Expenses (in $) in Belize and Expenses (in $) in Greece?
Your answer should be very brief. -8.48e+09. In the year 2003, what is the difference between the Expenses (in $) of Belize and Expenses (in $) of Trinidad and Tobago?
Offer a very short reply. -2.51e+09. In the year 2003, what is the difference between the Expenses (in $) in Greece and Expenses (in $) in Trinidad and Tobago?
Your answer should be compact. 5.97e+09. In the year 2004, what is the difference between the Expenses (in $) in Austria and Expenses (in $) in Belize?
Provide a succinct answer. 6.57e+09. In the year 2004, what is the difference between the Expenses (in $) in Austria and Expenses (in $) in Greece?
Keep it short and to the point. -2.20e+09. In the year 2004, what is the difference between the Expenses (in $) in Austria and Expenses (in $) in Trinidad and Tobago?
Ensure brevity in your answer.  4.35e+09. In the year 2004, what is the difference between the Expenses (in $) in Belize and Expenses (in $) in Greece?
Your answer should be compact. -8.77e+09. In the year 2004, what is the difference between the Expenses (in $) in Belize and Expenses (in $) in Trinidad and Tobago?
Give a very brief answer. -2.22e+09. In the year 2004, what is the difference between the Expenses (in $) in Greece and Expenses (in $) in Trinidad and Tobago?
Make the answer very short. 6.55e+09. In the year 2005, what is the difference between the Expenses (in $) of Austria and Expenses (in $) of Belize?
Give a very brief answer. 6.91e+09. In the year 2005, what is the difference between the Expenses (in $) of Austria and Expenses (in $) of Greece?
Make the answer very short. -1.90e+09. In the year 2005, what is the difference between the Expenses (in $) of Austria and Expenses (in $) of Trinidad and Tobago?
Your answer should be very brief. 4.52e+09. In the year 2005, what is the difference between the Expenses (in $) of Belize and Expenses (in $) of Greece?
Keep it short and to the point. -8.81e+09. In the year 2005, what is the difference between the Expenses (in $) of Belize and Expenses (in $) of Trinidad and Tobago?
Keep it short and to the point. -2.39e+09. In the year 2005, what is the difference between the Expenses (in $) in Greece and Expenses (in $) in Trinidad and Tobago?
Provide a succinct answer. 6.42e+09. In the year 2006, what is the difference between the Expenses (in $) in Austria and Expenses (in $) in Belize?
Provide a short and direct response. 6.91e+09. In the year 2006, what is the difference between the Expenses (in $) in Austria and Expenses (in $) in Greece?
Provide a short and direct response. -2.64e+09. In the year 2006, what is the difference between the Expenses (in $) in Austria and Expenses (in $) in Trinidad and Tobago?
Keep it short and to the point. 4.63e+09. In the year 2006, what is the difference between the Expenses (in $) in Belize and Expenses (in $) in Greece?
Make the answer very short. -9.56e+09. In the year 2006, what is the difference between the Expenses (in $) in Belize and Expenses (in $) in Trinidad and Tobago?
Provide a succinct answer. -2.28e+09. In the year 2006, what is the difference between the Expenses (in $) of Greece and Expenses (in $) of Trinidad and Tobago?
Provide a succinct answer. 7.27e+09. In the year 2007, what is the difference between the Expenses (in $) of Austria and Expenses (in $) of Belize?
Keep it short and to the point. 7.33e+09. In the year 2007, what is the difference between the Expenses (in $) of Austria and Expenses (in $) of Greece?
Your answer should be compact. -3.18e+09. In the year 2007, what is the difference between the Expenses (in $) of Austria and Expenses (in $) of Trinidad and Tobago?
Keep it short and to the point. 4.74e+09. In the year 2007, what is the difference between the Expenses (in $) in Belize and Expenses (in $) in Greece?
Provide a short and direct response. -1.05e+1. In the year 2007, what is the difference between the Expenses (in $) of Belize and Expenses (in $) of Trinidad and Tobago?
Provide a short and direct response. -2.59e+09. In the year 2007, what is the difference between the Expenses (in $) of Greece and Expenses (in $) of Trinidad and Tobago?
Your answer should be compact. 7.92e+09. In the year 2008, what is the difference between the Expenses (in $) of Austria and Expenses (in $) of Belize?
Give a very brief answer. 6.94e+09. In the year 2008, what is the difference between the Expenses (in $) in Austria and Expenses (in $) in Greece?
Your answer should be very brief. -4.81e+09. In the year 2008, what is the difference between the Expenses (in $) of Austria and Expenses (in $) of Trinidad and Tobago?
Your response must be concise. 4.08e+09. In the year 2008, what is the difference between the Expenses (in $) of Belize and Expenses (in $) of Greece?
Keep it short and to the point. -1.18e+1. In the year 2008, what is the difference between the Expenses (in $) in Belize and Expenses (in $) in Trinidad and Tobago?
Keep it short and to the point. -2.86e+09. In the year 2008, what is the difference between the Expenses (in $) of Greece and Expenses (in $) of Trinidad and Tobago?
Keep it short and to the point. 8.89e+09. In the year 2009, what is the difference between the Expenses (in $) in Austria and Expenses (in $) in Belize?
Give a very brief answer. 7.13e+09. In the year 2009, what is the difference between the Expenses (in $) of Austria and Expenses (in $) of Greece?
Provide a succinct answer. -4.60e+09. In the year 2009, what is the difference between the Expenses (in $) of Austria and Expenses (in $) of Trinidad and Tobago?
Provide a succinct answer. 3.73e+09. In the year 2009, what is the difference between the Expenses (in $) in Belize and Expenses (in $) in Greece?
Offer a very short reply. -1.17e+1. In the year 2009, what is the difference between the Expenses (in $) of Belize and Expenses (in $) of Trinidad and Tobago?
Offer a very short reply. -3.40e+09. In the year 2009, what is the difference between the Expenses (in $) of Greece and Expenses (in $) of Trinidad and Tobago?
Provide a short and direct response. 8.33e+09. What is the ratio of the Expenses (in $) in Austria in 2002 to that in 2003?
Give a very brief answer. 1.05. What is the ratio of the Expenses (in $) of Belize in 2002 to that in 2003?
Make the answer very short. 0.79. What is the ratio of the Expenses (in $) in Greece in 2002 to that in 2003?
Make the answer very short. 1.02. What is the ratio of the Expenses (in $) of Trinidad and Tobago in 2002 to that in 2003?
Give a very brief answer. 0.93. What is the ratio of the Expenses (in $) in Austria in 2002 to that in 2004?
Your answer should be compact. 1.05. What is the ratio of the Expenses (in $) of Belize in 2002 to that in 2004?
Provide a short and direct response. 0.36. What is the ratio of the Expenses (in $) in Greece in 2002 to that in 2004?
Provide a succinct answer. 0.97. What is the ratio of the Expenses (in $) of Austria in 2002 to that in 2005?
Make the answer very short. 1.01. What is the ratio of the Expenses (in $) in Belize in 2002 to that in 2005?
Offer a very short reply. 0.42. What is the ratio of the Expenses (in $) in Greece in 2002 to that in 2005?
Offer a very short reply. 0.97. What is the ratio of the Expenses (in $) in Trinidad and Tobago in 2002 to that in 2005?
Your response must be concise. 0.95. What is the ratio of the Expenses (in $) of Austria in 2002 to that in 2006?
Offer a terse response. 1. What is the ratio of the Expenses (in $) of Belize in 2002 to that in 2006?
Offer a terse response. 0.38. What is the ratio of the Expenses (in $) in Greece in 2002 to that in 2006?
Your answer should be compact. 0.89. What is the ratio of the Expenses (in $) in Trinidad and Tobago in 2002 to that in 2006?
Offer a terse response. 0.98. What is the ratio of the Expenses (in $) in Austria in 2002 to that in 2007?
Ensure brevity in your answer.  0.96. What is the ratio of the Expenses (in $) in Belize in 2002 to that in 2007?
Make the answer very short. 0.57. What is the ratio of the Expenses (in $) of Greece in 2002 to that in 2007?
Provide a short and direct response. 0.82. What is the ratio of the Expenses (in $) of Trinidad and Tobago in 2002 to that in 2007?
Provide a short and direct response. 0.89. What is the ratio of the Expenses (in $) in Austria in 2002 to that in 2008?
Provide a succinct answer. 1.01. What is the ratio of the Expenses (in $) in Belize in 2002 to that in 2008?
Make the answer very short. 0.62. What is the ratio of the Expenses (in $) in Greece in 2002 to that in 2008?
Provide a succinct answer. 0.73. What is the ratio of the Expenses (in $) of Trinidad and Tobago in 2002 to that in 2008?
Offer a terse response. 0.81. What is the ratio of the Expenses (in $) of Austria in 2002 to that in 2009?
Make the answer very short. 0.98. What is the ratio of the Expenses (in $) in Belize in 2002 to that in 2009?
Keep it short and to the point. 0.67. What is the ratio of the Expenses (in $) of Greece in 2002 to that in 2009?
Offer a very short reply. 0.74. What is the ratio of the Expenses (in $) of Trinidad and Tobago in 2002 to that in 2009?
Offer a terse response. 0.69. What is the ratio of the Expenses (in $) in Austria in 2003 to that in 2004?
Your answer should be very brief. 1. What is the ratio of the Expenses (in $) of Belize in 2003 to that in 2004?
Your response must be concise. 0.46. What is the ratio of the Expenses (in $) in Greece in 2003 to that in 2004?
Provide a succinct answer. 0.96. What is the ratio of the Expenses (in $) in Trinidad and Tobago in 2003 to that in 2004?
Your answer should be compact. 1.08. What is the ratio of the Expenses (in $) in Austria in 2003 to that in 2005?
Your answer should be very brief. 0.96. What is the ratio of the Expenses (in $) in Belize in 2003 to that in 2005?
Provide a succinct answer. 0.53. What is the ratio of the Expenses (in $) in Greece in 2003 to that in 2005?
Ensure brevity in your answer.  0.96. What is the ratio of the Expenses (in $) of Trinidad and Tobago in 2003 to that in 2005?
Provide a short and direct response. 1.02. What is the ratio of the Expenses (in $) of Austria in 2003 to that in 2006?
Your response must be concise. 0.95. What is the ratio of the Expenses (in $) in Belize in 2003 to that in 2006?
Your answer should be very brief. 0.48. What is the ratio of the Expenses (in $) of Greece in 2003 to that in 2006?
Make the answer very short. 0.88. What is the ratio of the Expenses (in $) of Trinidad and Tobago in 2003 to that in 2006?
Your answer should be very brief. 1.06. What is the ratio of the Expenses (in $) of Austria in 2003 to that in 2007?
Keep it short and to the point. 0.91. What is the ratio of the Expenses (in $) of Belize in 2003 to that in 2007?
Provide a succinct answer. 0.73. What is the ratio of the Expenses (in $) in Greece in 2003 to that in 2007?
Your answer should be compact. 0.81. What is the ratio of the Expenses (in $) in Trinidad and Tobago in 2003 to that in 2007?
Your answer should be very brief. 0.96. What is the ratio of the Expenses (in $) in Austria in 2003 to that in 2008?
Your answer should be compact. 0.96. What is the ratio of the Expenses (in $) of Belize in 2003 to that in 2008?
Provide a succinct answer. 0.79. What is the ratio of the Expenses (in $) of Greece in 2003 to that in 2008?
Make the answer very short. 0.72. What is the ratio of the Expenses (in $) in Trinidad and Tobago in 2003 to that in 2008?
Keep it short and to the point. 0.87. What is the ratio of the Expenses (in $) in Austria in 2003 to that in 2009?
Offer a terse response. 0.94. What is the ratio of the Expenses (in $) of Belize in 2003 to that in 2009?
Your answer should be very brief. 0.85. What is the ratio of the Expenses (in $) of Greece in 2003 to that in 2009?
Your answer should be very brief. 0.72. What is the ratio of the Expenses (in $) of Trinidad and Tobago in 2003 to that in 2009?
Provide a succinct answer. 0.74. What is the ratio of the Expenses (in $) of Austria in 2004 to that in 2005?
Offer a very short reply. 0.95. What is the ratio of the Expenses (in $) of Belize in 2004 to that in 2005?
Give a very brief answer. 1.14. What is the ratio of the Expenses (in $) of Trinidad and Tobago in 2004 to that in 2005?
Give a very brief answer. 0.94. What is the ratio of the Expenses (in $) of Austria in 2004 to that in 2006?
Provide a succinct answer. 0.95. What is the ratio of the Expenses (in $) of Belize in 2004 to that in 2006?
Provide a succinct answer. 1.03. What is the ratio of the Expenses (in $) of Greece in 2004 to that in 2006?
Make the answer very short. 0.92. What is the ratio of the Expenses (in $) of Trinidad and Tobago in 2004 to that in 2006?
Your answer should be compact. 0.98. What is the ratio of the Expenses (in $) in Austria in 2004 to that in 2007?
Your answer should be very brief. 0.91. What is the ratio of the Expenses (in $) in Belize in 2004 to that in 2007?
Provide a succinct answer. 1.58. What is the ratio of the Expenses (in $) in Greece in 2004 to that in 2007?
Keep it short and to the point. 0.84. What is the ratio of the Expenses (in $) of Trinidad and Tobago in 2004 to that in 2007?
Keep it short and to the point. 0.89. What is the ratio of the Expenses (in $) in Austria in 2004 to that in 2008?
Offer a terse response. 0.96. What is the ratio of the Expenses (in $) of Belize in 2004 to that in 2008?
Your answer should be compact. 1.72. What is the ratio of the Expenses (in $) in Greece in 2004 to that in 2008?
Your answer should be compact. 0.75. What is the ratio of the Expenses (in $) of Trinidad and Tobago in 2004 to that in 2008?
Offer a terse response. 0.81. What is the ratio of the Expenses (in $) in Austria in 2004 to that in 2009?
Provide a short and direct response. 0.93. What is the ratio of the Expenses (in $) of Belize in 2004 to that in 2009?
Your answer should be very brief. 1.84. What is the ratio of the Expenses (in $) in Greece in 2004 to that in 2009?
Make the answer very short. 0.76. What is the ratio of the Expenses (in $) in Trinidad and Tobago in 2004 to that in 2009?
Make the answer very short. 0.68. What is the ratio of the Expenses (in $) in Austria in 2005 to that in 2006?
Your answer should be compact. 1. What is the ratio of the Expenses (in $) in Belize in 2005 to that in 2006?
Offer a terse response. 0.9. What is the ratio of the Expenses (in $) of Greece in 2005 to that in 2006?
Give a very brief answer. 0.92. What is the ratio of the Expenses (in $) in Trinidad and Tobago in 2005 to that in 2006?
Ensure brevity in your answer.  1.04. What is the ratio of the Expenses (in $) in Austria in 2005 to that in 2007?
Your response must be concise. 0.95. What is the ratio of the Expenses (in $) in Belize in 2005 to that in 2007?
Ensure brevity in your answer.  1.38. What is the ratio of the Expenses (in $) in Greece in 2005 to that in 2007?
Provide a short and direct response. 0.84. What is the ratio of the Expenses (in $) of Trinidad and Tobago in 2005 to that in 2007?
Your answer should be compact. 0.94. What is the ratio of the Expenses (in $) of Austria in 2005 to that in 2008?
Provide a succinct answer. 1. What is the ratio of the Expenses (in $) of Belize in 2005 to that in 2008?
Offer a very short reply. 1.5. What is the ratio of the Expenses (in $) of Greece in 2005 to that in 2008?
Offer a very short reply. 0.76. What is the ratio of the Expenses (in $) of Trinidad and Tobago in 2005 to that in 2008?
Provide a succinct answer. 0.86. What is the ratio of the Expenses (in $) of Austria in 2005 to that in 2009?
Keep it short and to the point. 0.98. What is the ratio of the Expenses (in $) of Belize in 2005 to that in 2009?
Ensure brevity in your answer.  1.6. What is the ratio of the Expenses (in $) in Greece in 2005 to that in 2009?
Provide a short and direct response. 0.76. What is the ratio of the Expenses (in $) of Trinidad and Tobago in 2005 to that in 2009?
Ensure brevity in your answer.  0.73. What is the ratio of the Expenses (in $) in Austria in 2006 to that in 2007?
Give a very brief answer. 0.95. What is the ratio of the Expenses (in $) in Belize in 2006 to that in 2007?
Give a very brief answer. 1.53. What is the ratio of the Expenses (in $) in Greece in 2006 to that in 2007?
Ensure brevity in your answer.  0.92. What is the ratio of the Expenses (in $) of Trinidad and Tobago in 2006 to that in 2007?
Ensure brevity in your answer.  0.91. What is the ratio of the Expenses (in $) of Belize in 2006 to that in 2008?
Make the answer very short. 1.66. What is the ratio of the Expenses (in $) in Greece in 2006 to that in 2008?
Give a very brief answer. 0.82. What is the ratio of the Expenses (in $) in Trinidad and Tobago in 2006 to that in 2008?
Provide a succinct answer. 0.83. What is the ratio of the Expenses (in $) in Austria in 2006 to that in 2009?
Make the answer very short. 0.98. What is the ratio of the Expenses (in $) in Belize in 2006 to that in 2009?
Offer a terse response. 1.78. What is the ratio of the Expenses (in $) of Greece in 2006 to that in 2009?
Keep it short and to the point. 0.82. What is the ratio of the Expenses (in $) in Trinidad and Tobago in 2006 to that in 2009?
Your response must be concise. 0.7. What is the ratio of the Expenses (in $) of Austria in 2007 to that in 2008?
Offer a very short reply. 1.06. What is the ratio of the Expenses (in $) of Belize in 2007 to that in 2008?
Your answer should be compact. 1.09. What is the ratio of the Expenses (in $) of Greece in 2007 to that in 2008?
Ensure brevity in your answer.  0.9. What is the ratio of the Expenses (in $) in Trinidad and Tobago in 2007 to that in 2008?
Offer a terse response. 0.91. What is the ratio of the Expenses (in $) of Austria in 2007 to that in 2009?
Your answer should be compact. 1.03. What is the ratio of the Expenses (in $) of Belize in 2007 to that in 2009?
Offer a terse response. 1.16. What is the ratio of the Expenses (in $) of Greece in 2007 to that in 2009?
Make the answer very short. 0.9. What is the ratio of the Expenses (in $) of Trinidad and Tobago in 2007 to that in 2009?
Keep it short and to the point. 0.77. What is the ratio of the Expenses (in $) of Austria in 2008 to that in 2009?
Make the answer very short. 0.97. What is the ratio of the Expenses (in $) of Belize in 2008 to that in 2009?
Offer a terse response. 1.07. What is the ratio of the Expenses (in $) of Greece in 2008 to that in 2009?
Provide a short and direct response. 1. What is the ratio of the Expenses (in $) of Trinidad and Tobago in 2008 to that in 2009?
Make the answer very short. 0.85. What is the difference between the highest and the second highest Expenses (in $) of Austria?
Your answer should be very brief. 2.08e+08. What is the difference between the highest and the second highest Expenses (in $) of Belize?
Offer a very short reply. 5.65e+06. What is the difference between the highest and the second highest Expenses (in $) in Greece?
Ensure brevity in your answer.  2.30e+07. What is the difference between the highest and the second highest Expenses (in $) of Trinidad and Tobago?
Give a very brief answer. 5.33e+08. What is the difference between the highest and the lowest Expenses (in $) in Austria?
Offer a very short reply. 6.90e+08. What is the difference between the highest and the lowest Expenses (in $) in Belize?
Ensure brevity in your answer.  1.12e+08. What is the difference between the highest and the lowest Expenses (in $) of Greece?
Your answer should be very brief. 3.29e+09. What is the difference between the highest and the lowest Expenses (in $) in Trinidad and Tobago?
Provide a short and direct response. 1.10e+09. 